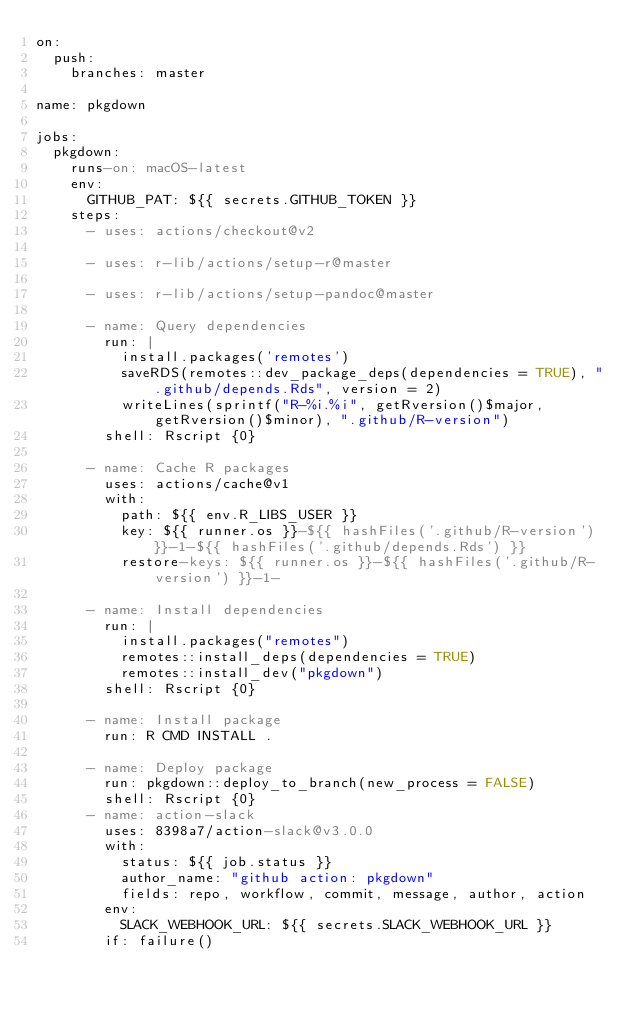Convert code to text. <code><loc_0><loc_0><loc_500><loc_500><_YAML_>on:
  push:
    branches: master

name: pkgdown

jobs:
  pkgdown:
    runs-on: macOS-latest
    env:
      GITHUB_PAT: ${{ secrets.GITHUB_TOKEN }}
    steps:
      - uses: actions/checkout@v2

      - uses: r-lib/actions/setup-r@master

      - uses: r-lib/actions/setup-pandoc@master

      - name: Query dependencies
        run: |
          install.packages('remotes')
          saveRDS(remotes::dev_package_deps(dependencies = TRUE), ".github/depends.Rds", version = 2)
          writeLines(sprintf("R-%i.%i", getRversion()$major, getRversion()$minor), ".github/R-version")
        shell: Rscript {0}

      - name: Cache R packages
        uses: actions/cache@v1
        with:
          path: ${{ env.R_LIBS_USER }}
          key: ${{ runner.os }}-${{ hashFiles('.github/R-version') }}-1-${{ hashFiles('.github/depends.Rds') }}
          restore-keys: ${{ runner.os }}-${{ hashFiles('.github/R-version') }}-1-

      - name: Install dependencies
        run: |
          install.packages("remotes")
          remotes::install_deps(dependencies = TRUE)
          remotes::install_dev("pkgdown")
        shell: Rscript {0}

      - name: Install package
        run: R CMD INSTALL .

      - name: Deploy package
        run: pkgdown::deploy_to_branch(new_process = FALSE)
        shell: Rscript {0}
      - name: action-slack
        uses: 8398a7/action-slack@v3.0.0
        with:
          status: ${{ job.status }}
          author_name: "github action: pkgdown"
          fields: repo, workflow, commit, message, author, action
        env:
          SLACK_WEBHOOK_URL: ${{ secrets.SLACK_WEBHOOK_URL }}
        if: failure()
</code> 